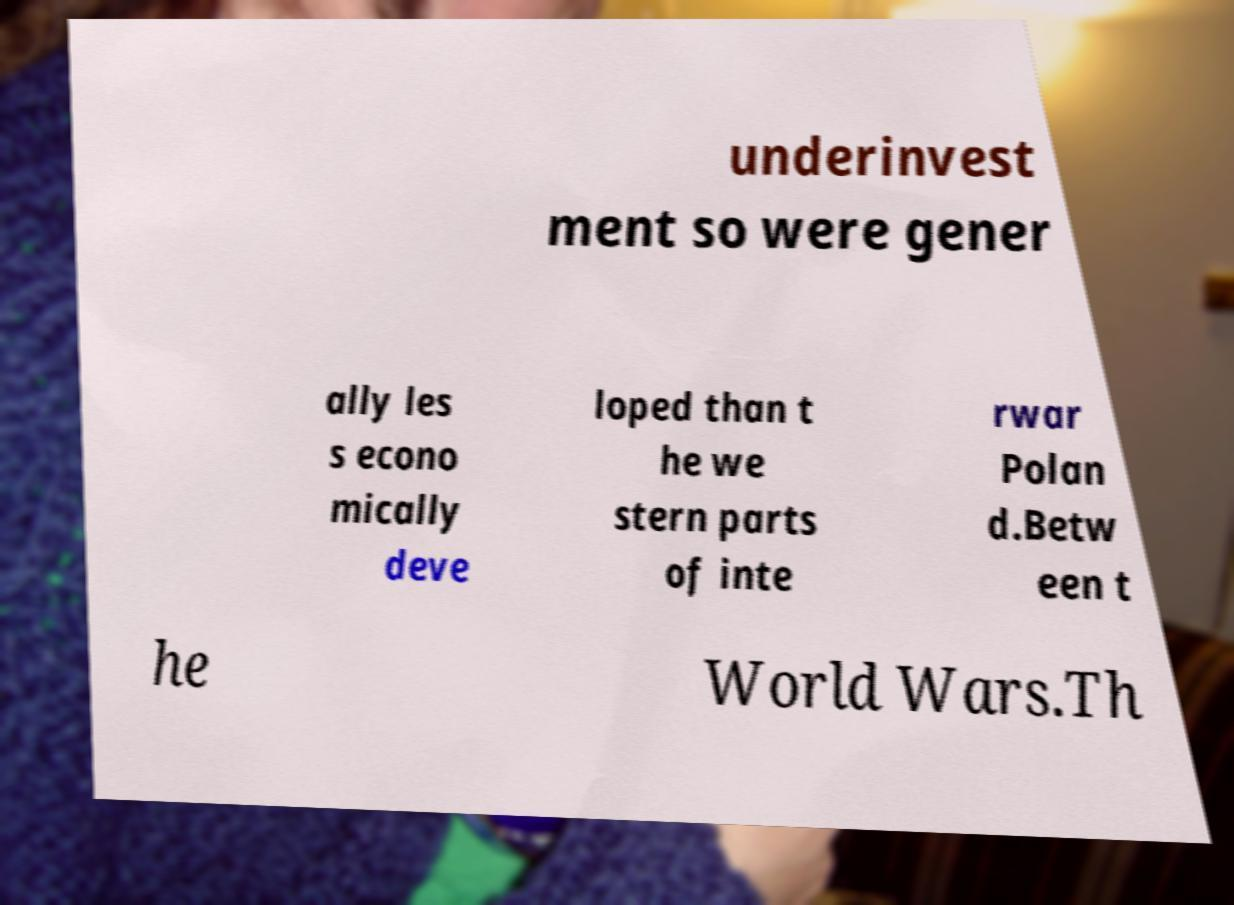Could you assist in decoding the text presented in this image and type it out clearly? underinvest ment so were gener ally les s econo mically deve loped than t he we stern parts of inte rwar Polan d.Betw een t he World Wars.Th 